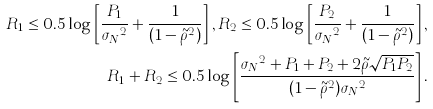Convert formula to latex. <formula><loc_0><loc_0><loc_500><loc_500>R _ { 1 } \leq 0 . 5 \log \left [ \frac { P _ { 1 } } { { \sigma _ { N } } ^ { 2 } } + \frac { 1 } { ( 1 - { \tilde { \rho } } ^ { 2 } ) } \right ] , R _ { 2 } \leq 0 . 5 \log \left [ \frac { P _ { 2 } } { { \sigma _ { N } } ^ { 2 } } + \frac { 1 } { ( 1 - { \tilde { \rho } } ^ { 2 } ) } \right ] , \\ R _ { 1 } + R _ { 2 } \leq 0 . 5 \log \left [ \frac { { \sigma _ { N } } ^ { 2 } + P _ { 1 } + P _ { 2 } + { 2 } { \tilde { \rho } } { \sqrt { P _ { 1 } P _ { 2 } } } } { { ( 1 - { \tilde { \rho } } ^ { 2 } ) } { \sigma _ { N } } ^ { 2 } } \right ] .</formula> 